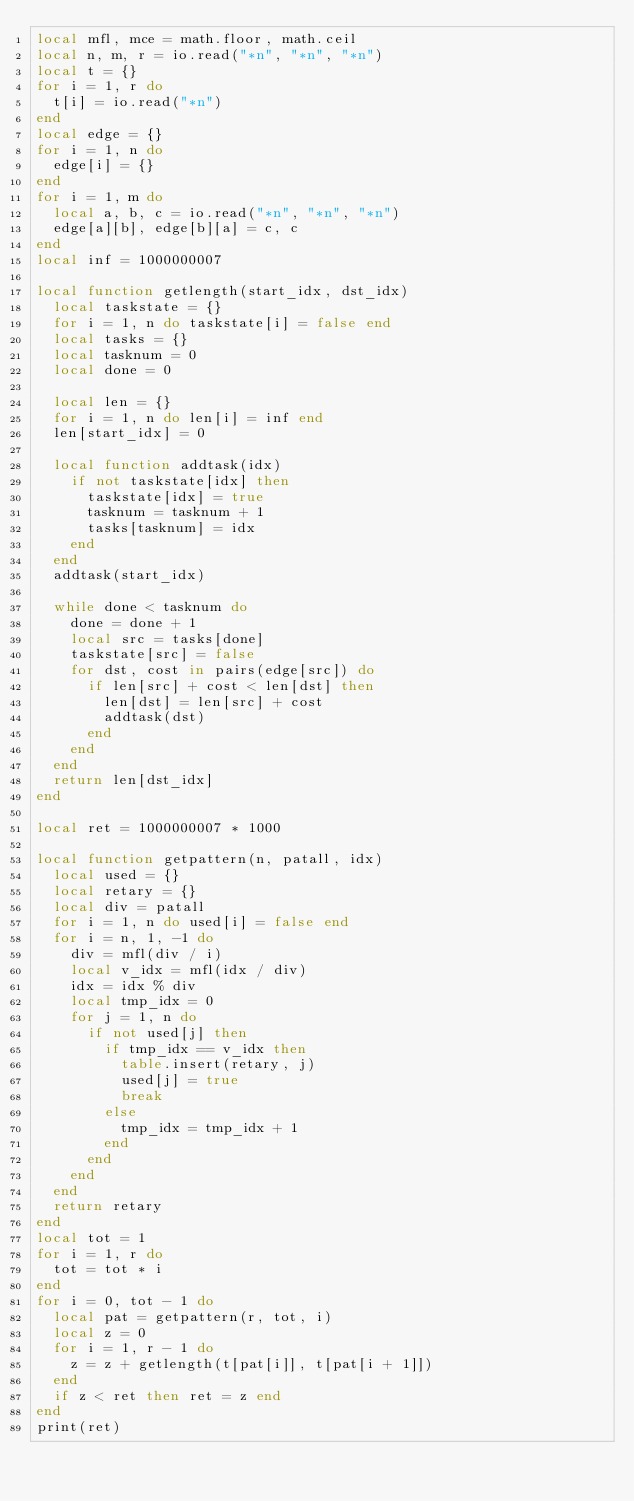Convert code to text. <code><loc_0><loc_0><loc_500><loc_500><_Lua_>local mfl, mce = math.floor, math.ceil
local n, m, r = io.read("*n", "*n", "*n")
local t = {}
for i = 1, r do
  t[i] = io.read("*n")
end
local edge = {}
for i = 1, n do
  edge[i] = {}
end
for i = 1, m do
  local a, b, c = io.read("*n", "*n", "*n")
  edge[a][b], edge[b][a] = c, c
end
local inf = 1000000007

local function getlength(start_idx, dst_idx)
  local taskstate = {}
  for i = 1, n do taskstate[i] = false end
  local tasks = {}
  local tasknum = 0
  local done = 0

  local len = {}
  for i = 1, n do len[i] = inf end
  len[start_idx] = 0

  local function addtask(idx)
    if not taskstate[idx] then
      taskstate[idx] = true
      tasknum = tasknum + 1
      tasks[tasknum] = idx
    end
  end
  addtask(start_idx)

  while done < tasknum do
    done = done + 1
    local src = tasks[done]
    taskstate[src] = false
    for dst, cost in pairs(edge[src]) do
      if len[src] + cost < len[dst] then
        len[dst] = len[src] + cost
        addtask(dst)
      end
    end
  end
  return len[dst_idx]
end

local ret = 1000000007 * 1000

local function getpattern(n, patall, idx)
  local used = {}
  local retary = {}
  local div = patall
  for i = 1, n do used[i] = false end
  for i = n, 1, -1 do
    div = mfl(div / i)
    local v_idx = mfl(idx / div)
    idx = idx % div
    local tmp_idx = 0
    for j = 1, n do
      if not used[j] then
        if tmp_idx == v_idx then
          table.insert(retary, j)
          used[j] = true
          break
        else
          tmp_idx = tmp_idx + 1
        end
      end
    end
  end
  return retary
end
local tot = 1
for i = 1, r do
  tot = tot * i
end
for i = 0, tot - 1 do
  local pat = getpattern(r, tot, i)
  local z = 0
  for i = 1, r - 1 do
    z = z + getlength(t[pat[i]], t[pat[i + 1]])
  end
  if z < ret then ret = z end
end
print(ret)
</code> 